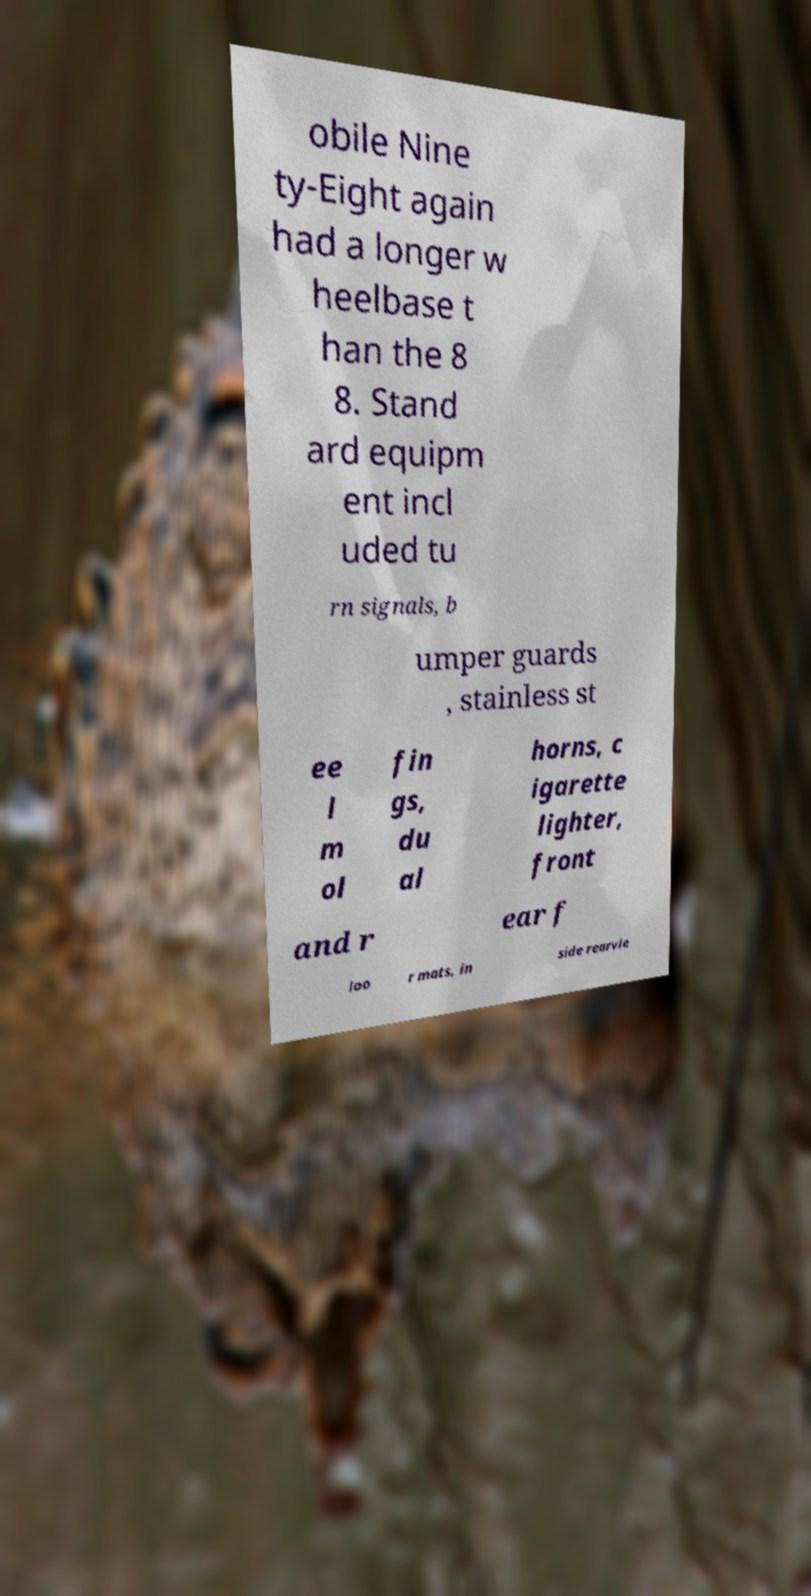Please identify and transcribe the text found in this image. obile Nine ty-Eight again had a longer w heelbase t han the 8 8. Stand ard equipm ent incl uded tu rn signals, b umper guards , stainless st ee l m ol fin gs, du al horns, c igarette lighter, front and r ear f loo r mats, in side rearvie 